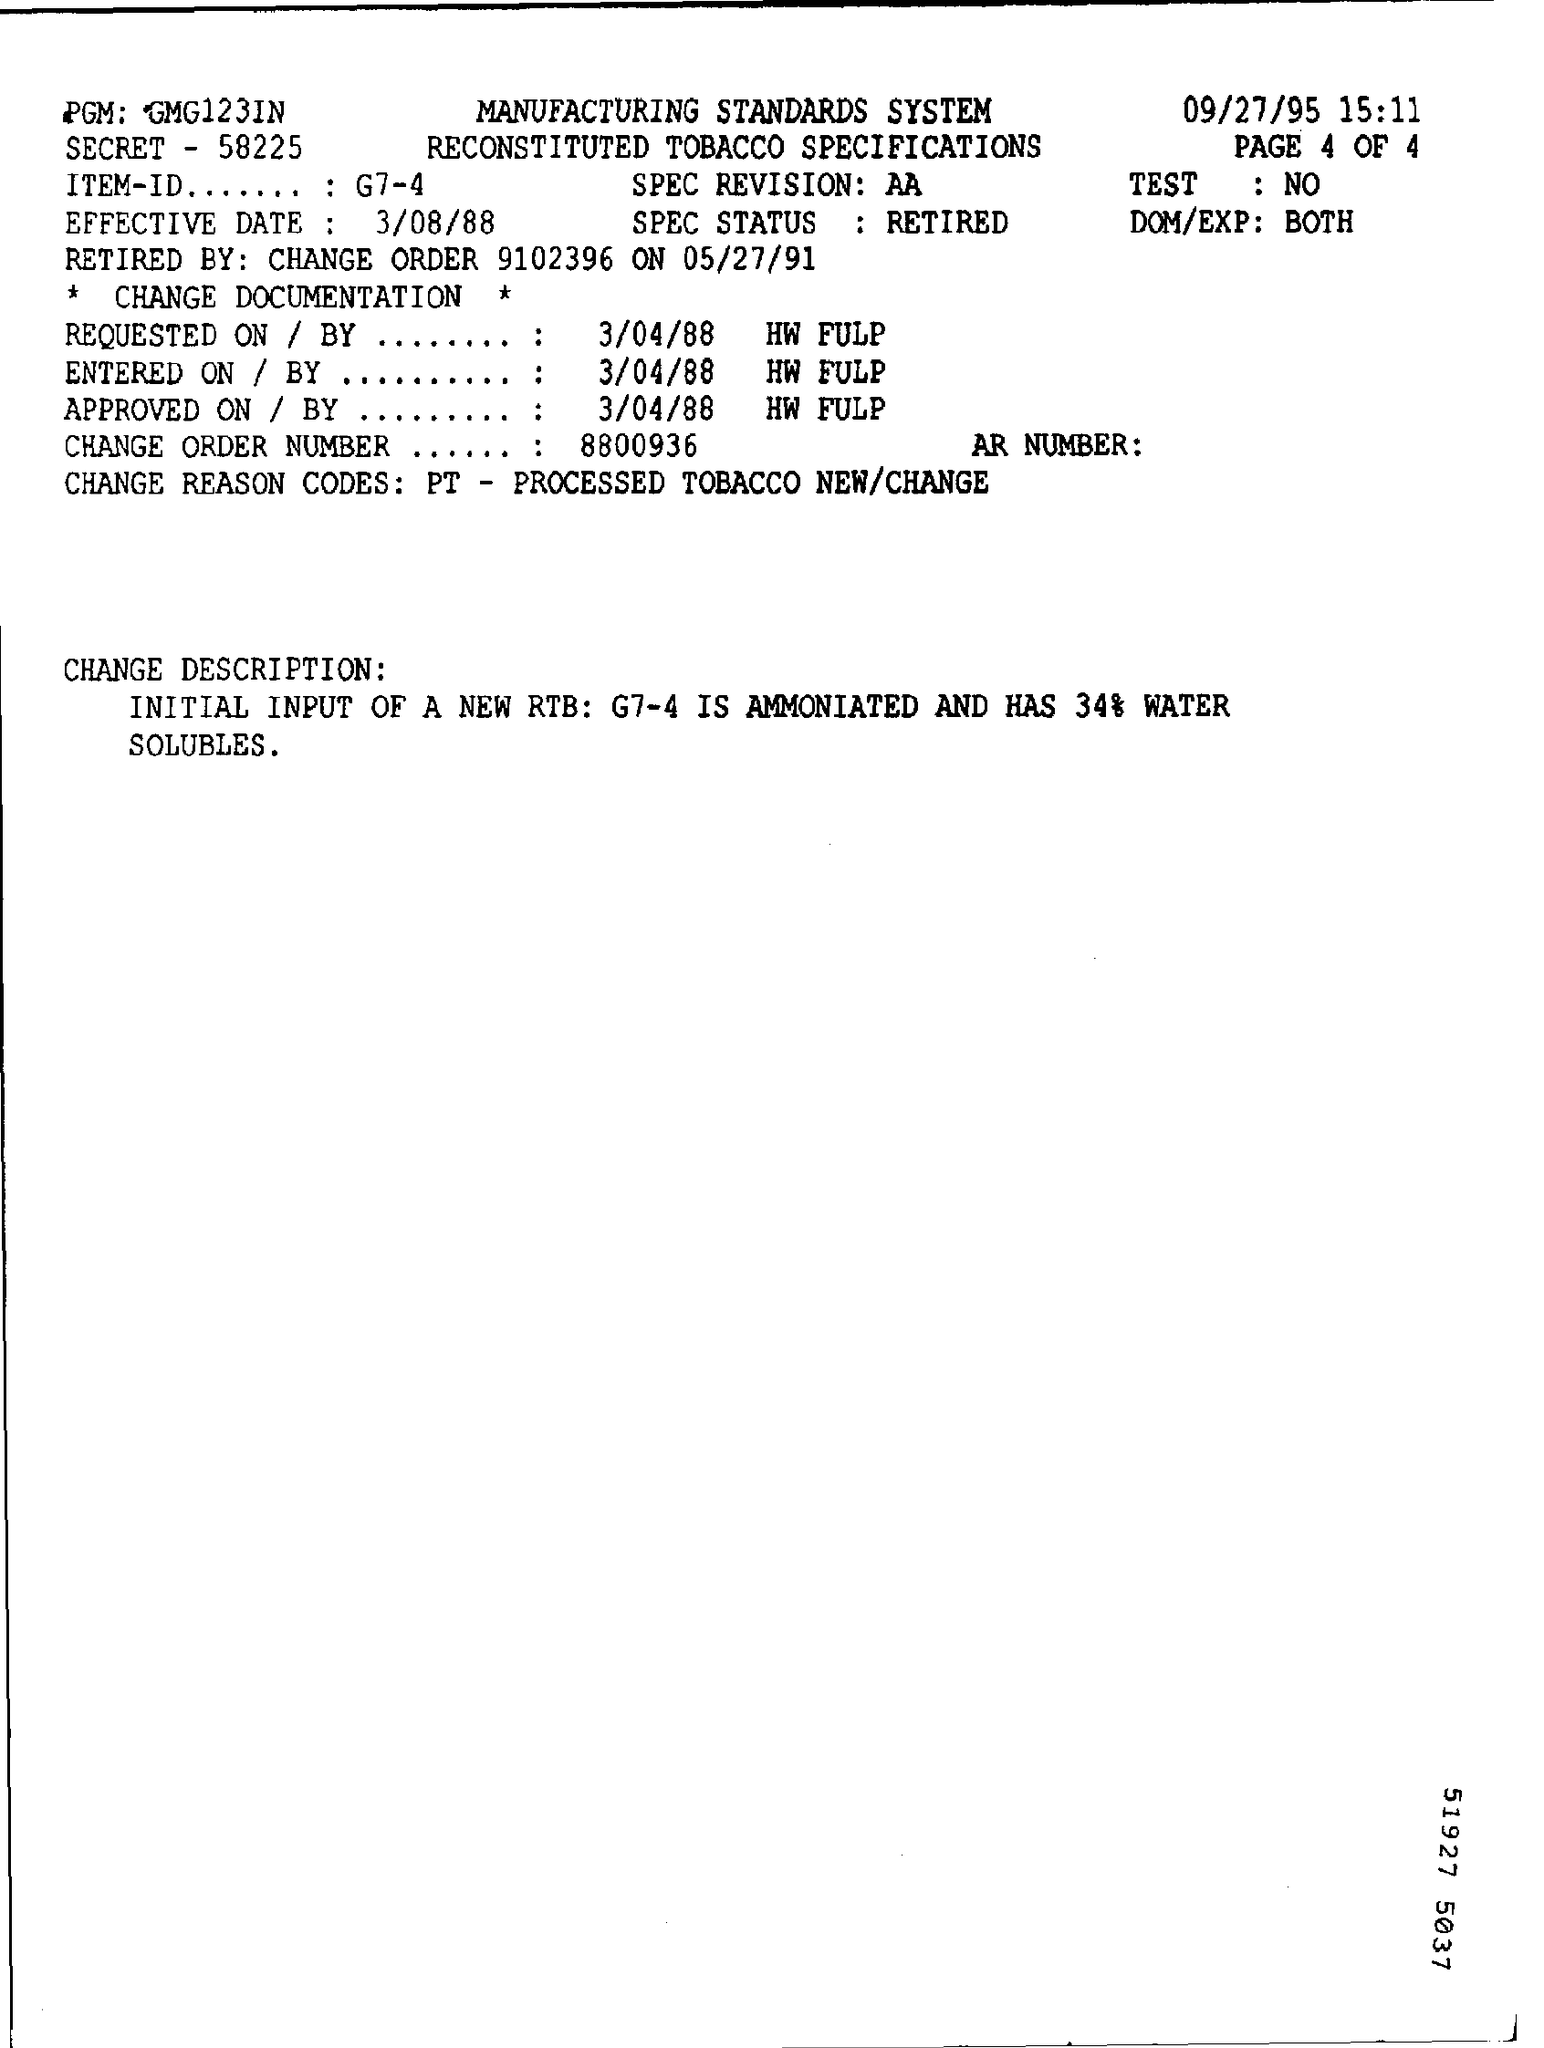Indicate a few pertinent items in this graphic. The effective date of March 8, 1988, has been noted. The SPEC Status is retired. 